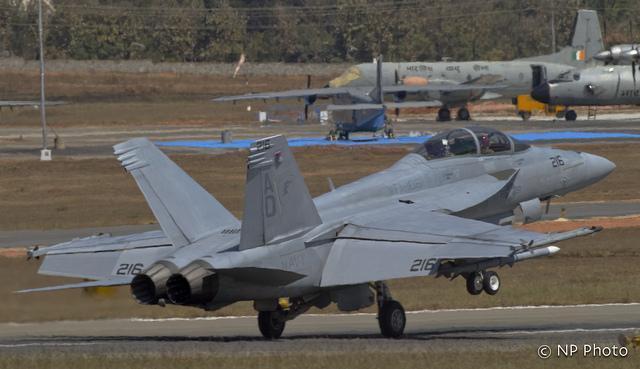How many airplanes are in the photo?
Give a very brief answer. 4. How many couches are there?
Give a very brief answer. 0. 